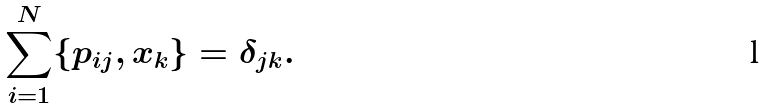<formula> <loc_0><loc_0><loc_500><loc_500>\sum _ { i = 1 } ^ { N } \{ p _ { i j } , x _ { k } \} = \delta _ { j k } .</formula> 